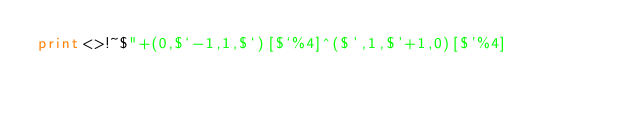Convert code to text. <code><loc_0><loc_0><loc_500><loc_500><_Perl_>print<>!~$"+(0,$`-1,1,$`)[$`%4]^($',1,$'+1,0)[$'%4]</code> 